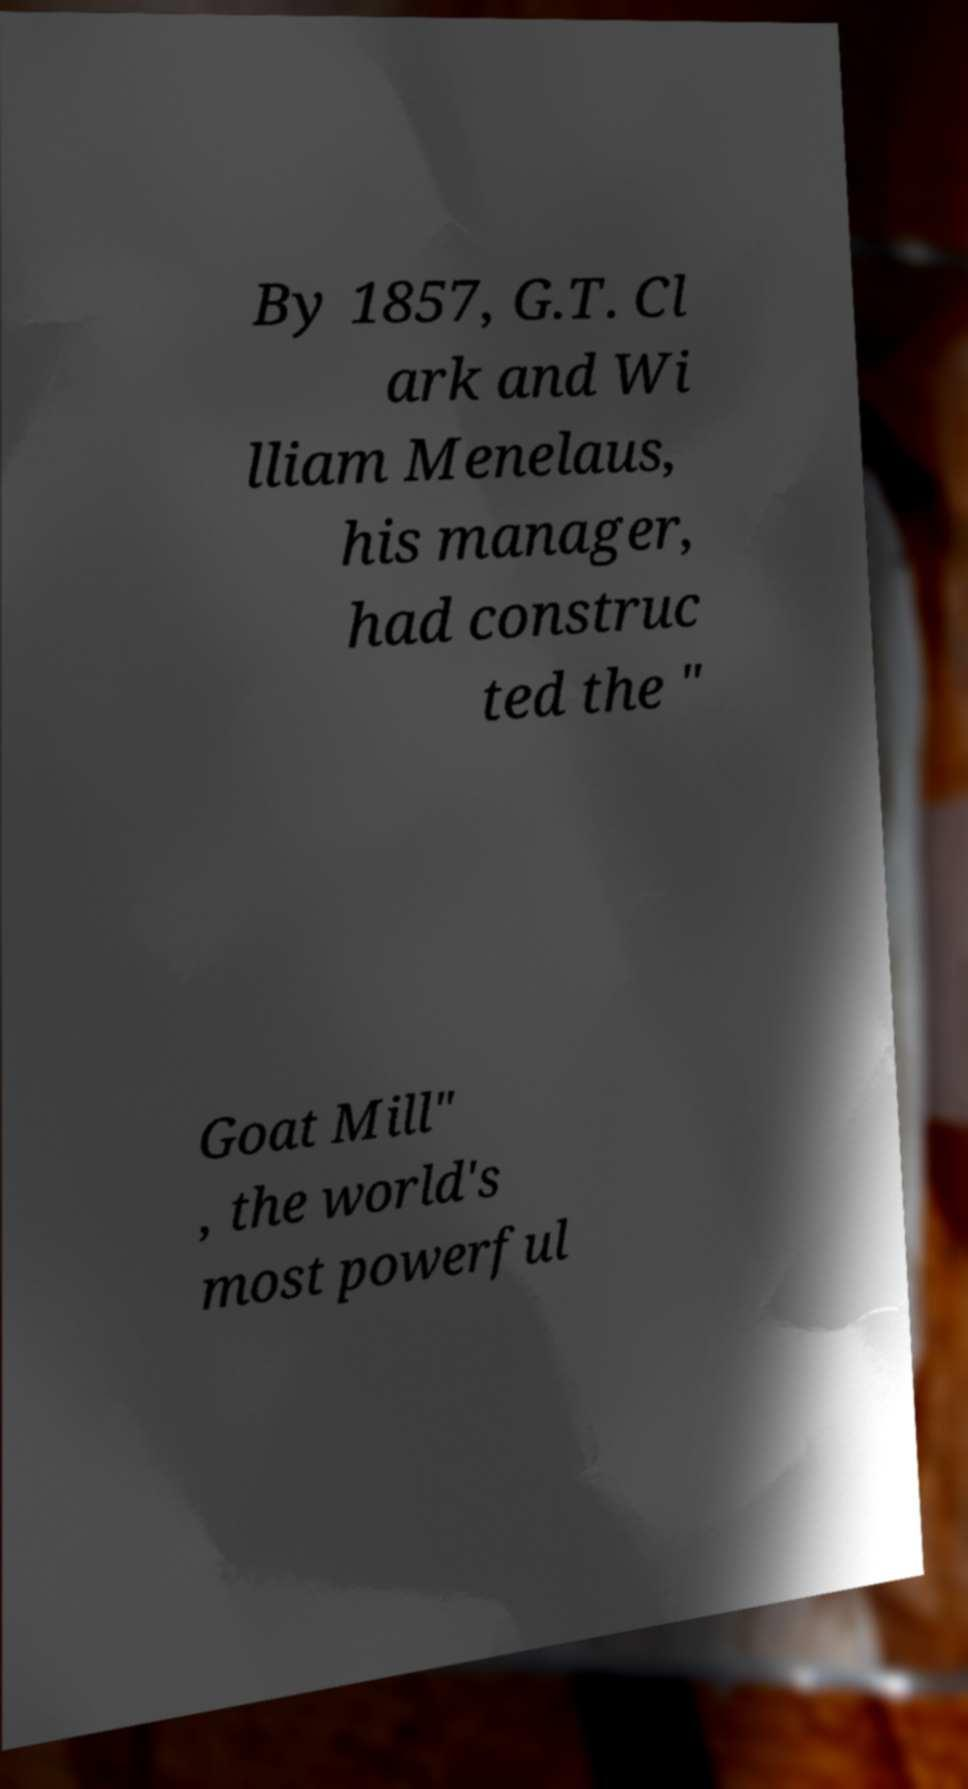There's text embedded in this image that I need extracted. Can you transcribe it verbatim? By 1857, G.T. Cl ark and Wi lliam Menelaus, his manager, had construc ted the " Goat Mill" , the world's most powerful 